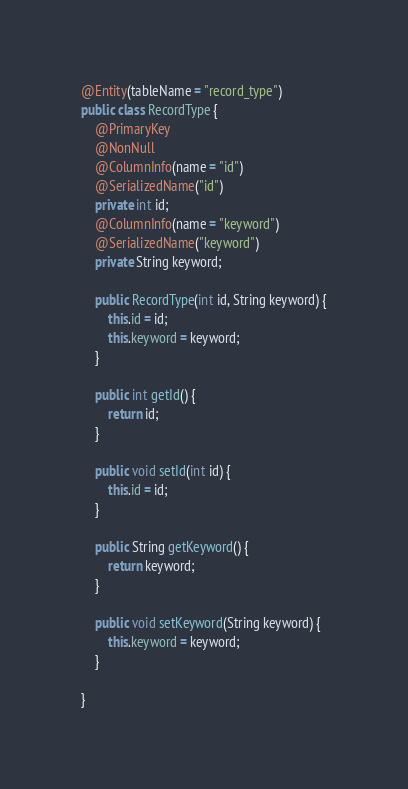Convert code to text. <code><loc_0><loc_0><loc_500><loc_500><_Java_>
@Entity(tableName = "record_type")
public class RecordType {
    @PrimaryKey
    @NonNull
    @ColumnInfo(name = "id")
    @SerializedName("id")
    private int id;
    @ColumnInfo(name = "keyword")
    @SerializedName("keyword")
    private String keyword;

    public RecordType(int id, String keyword) {
        this.id = id;
        this.keyword = keyword;
    }

    public int getId() {
        return id;
    }

    public void setId(int id) {
        this.id = id;
    }

    public String getKeyword() {
        return keyword;
    }

    public void setKeyword(String keyword) {
        this.keyword = keyword;
    }

}</code> 